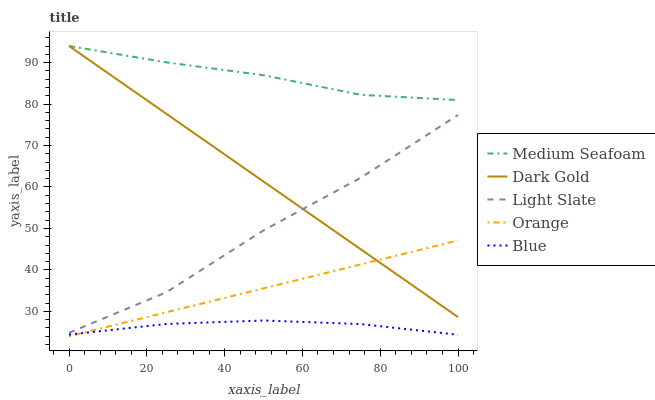Does Blue have the minimum area under the curve?
Answer yes or no. Yes. Does Medium Seafoam have the maximum area under the curve?
Answer yes or no. Yes. Does Orange have the minimum area under the curve?
Answer yes or no. No. Does Orange have the maximum area under the curve?
Answer yes or no. No. Is Orange the smoothest?
Answer yes or no. Yes. Is Light Slate the roughest?
Answer yes or no. Yes. Is Medium Seafoam the smoothest?
Answer yes or no. No. Is Medium Seafoam the roughest?
Answer yes or no. No. Does Medium Seafoam have the lowest value?
Answer yes or no. No. Does Orange have the highest value?
Answer yes or no. No. Is Orange less than Medium Seafoam?
Answer yes or no. Yes. Is Medium Seafoam greater than Blue?
Answer yes or no. Yes. Does Orange intersect Medium Seafoam?
Answer yes or no. No. 